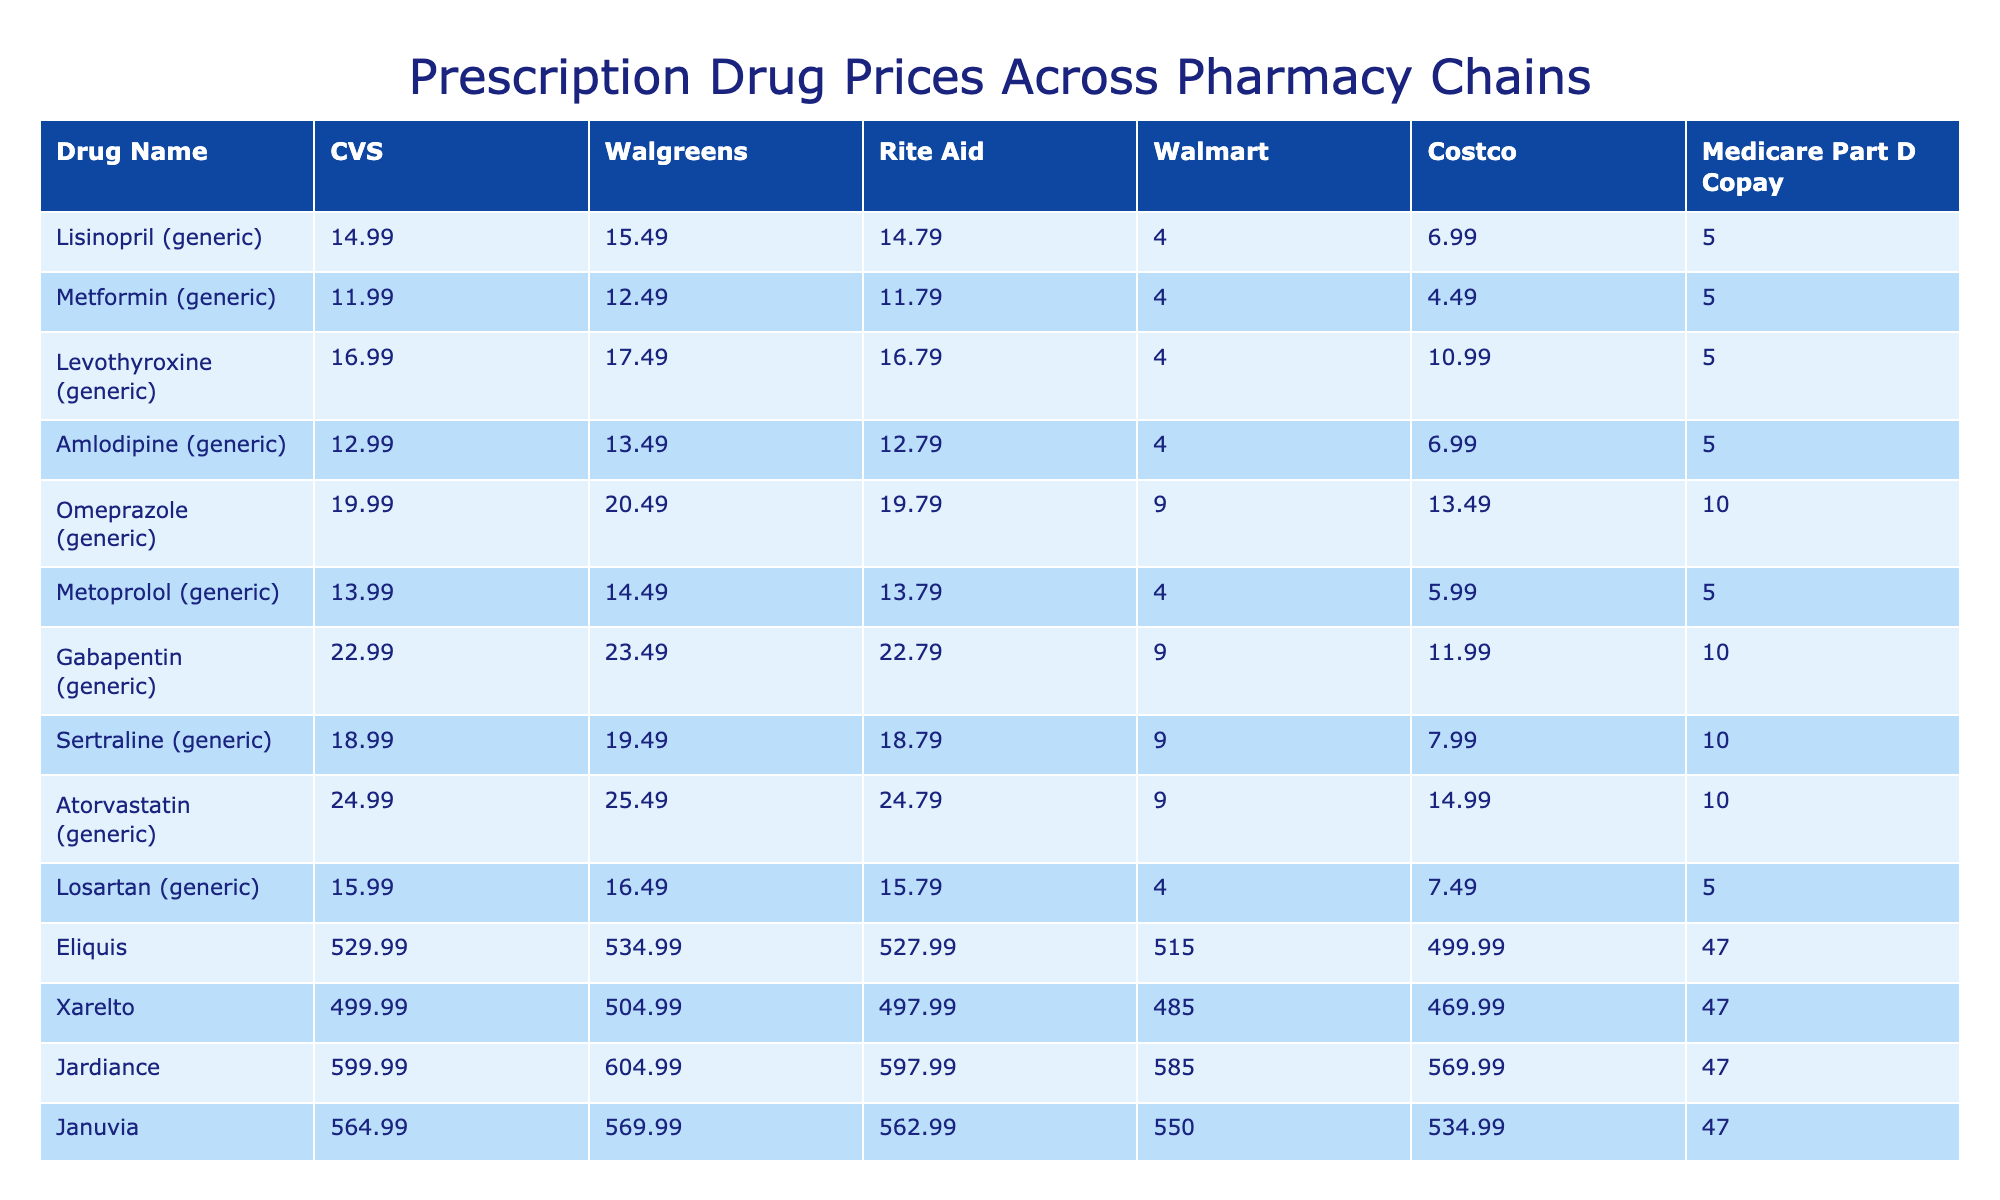What is the price of Lisinopril at Walmart? The price for Lisinopril (generic) listed under Walmart in the table is 4.00.
Answer: 4.00 How much does Medicare Part D copay for Atorvastatin? The Medicare Part D copay for Atorvastatin (generic) is 10.00 according to the table.
Answer: 10.00 Which pharmacy offers the lowest price for Metformin? From the table, Walmart offers the lowest price for Metformin (generic) at 4.00, compared to other pharmacies.
Answer: Walmart What is the price difference of Eliquis between CVS and Costco? The price for Eliquis at CVS is 529.99 and at Costco is 499.99. The difference is 529.99 - 499.99 = 30.00.
Answer: 30.00 Which pharmacy has the highest price for Gabapentin? The highest price for Gabapentin (generic) is at Walgreens for 23.49 as per the table.
Answer: Walgreens Is the Medicare Part D copay for Humira less than the price at Walgreens? Walmart shows Humira priced at 6929.99 at Walgreens, and the Medicare Part D copay is 250.00. Since 250.00 is less than 6929.99, the answer is yes.
Answer: Yes What is the average price of the drug Lisinopril across all pharmacies? The prices across the pharmacies for Lisinopril are 14.99, 15.49, 14.79, 4.00, 6.99. Adding these gives us 56.25, and dividing by 5 results in an average price of 11.25.
Answer: 11.25 How does the price of Metoprolol compare with Amlodipine at Costco? At Costco, Metoprolol is 5.99 while Amlodipine is 6.99. The price of Metoprolol is lower by 6.99 - 5.99 = 1.00.
Answer: 1.00 Among the listed pharmacies, which has the most expensive price for Humira? The prices for Humira are 6899.99 (CVS), 6929.99 (Walgreens), 6879.99 (Rite Aid), 6799.00 (Walmart), and 6699.99 (Costco), making Walgreens the highest at 6929.99.
Answer: Walgreens What is the total cost of drugs listed at Walgreens? To find the total, sum the prices at Walgreens: 15.49 + 12.49 + 17.49 + 13.49 + 20.49 + 14.49 + 23.49 + 19.49 + 25.49 + 16.49 + 534.99 + 504.99 + 604.99 + 569.99 + 6929.99 = 7337.91.
Answer: 7337.91 